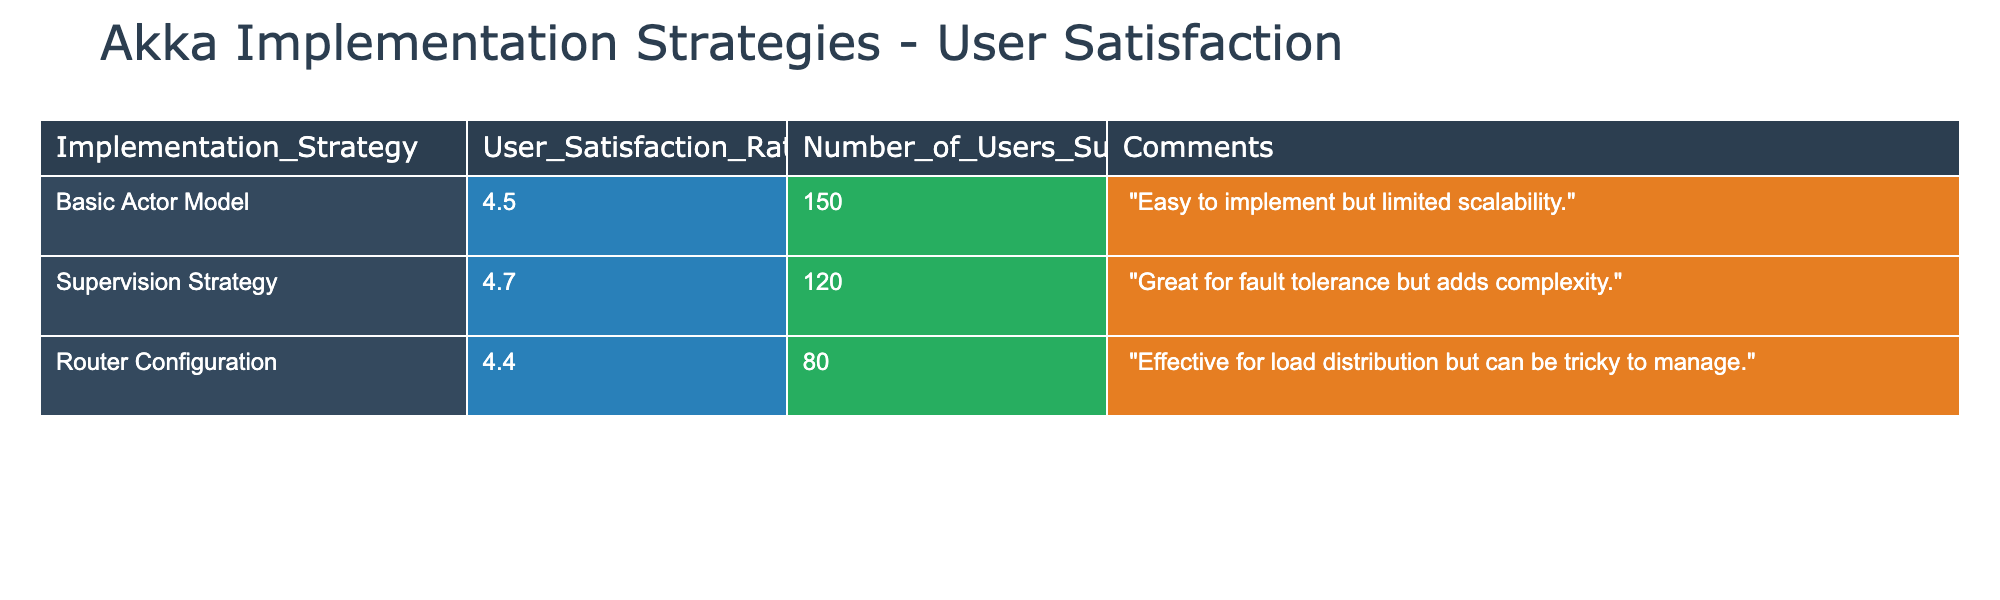What is the user satisfaction rating for the Supervision Strategy? The table directly lists the user satisfaction rating for each implementation strategy. The Supervision Strategy has a user satisfaction rating of 4.7.
Answer: 4.7 How many users were surveyed for the Basic Actor Model implementation? The Basic Actor Model row in the table shows that 150 users were surveyed, which can be answered by directly referring to that row.
Answer: 150 What is the average user satisfaction rating across all implementation strategies? To find the average, sum the ratings: (4.5 + 4.7 + 4.4) = 13.6 and divide by the number of strategies: 13.6 / 3 = 4.53.
Answer: 4.53 Did the Router Configuration receive a higher satisfaction rating than the Basic Actor Model? The satisfaction rating for Router Configuration is 4.4, and for the Basic Actor Model, it is 4.5. Since 4.4 is less than 4.5, the answer is no.
Answer: No What is the total number of users surveyed across all strategies? The number of users surveyed for each strategy is given in the table: 150 (Basic Actor Model) + 120 (Supervision Strategy) + 80 (Router Configuration) = 350.
Answer: 350 How does the user satisfaction rating of the Supervision Strategy compare to the Basic Actor Model? The Supervision Strategy has a rating of 4.7, while the Basic Actor Model has a rating of 4.5. Since 4.7 is greater than 4.5, the Supervision Strategy has a higher rating.
Answer: Higher Which implementation strategy has the lowest user satisfaction rating? By comparing the satisfaction ratings listed, the Router Configuration has the lowest rating of 4.4 compared to the others (4.5 and 4.7).
Answer: Router Configuration Is the comment for the Supervision Strategy focused more on positive or negative aspects? The comment for the Supervision Strategy states it is "great for fault tolerance but adds complexity." This suggests a mix of both positive ("great for fault tolerance") and negative ("adds complexity") aspects.
Answer: Mixed What percentage of the users surveyed reported satisfaction ratings of 4.5 or higher? The total number of users surveyed is 350. The number of users giving ratings of 4.5 or higher is from the Basic Actor Model (150) and Supervision Strategy (120), totaling 270. The percentage is (270 / 350) * 100 = 77.14%.
Answer: 77.14% 